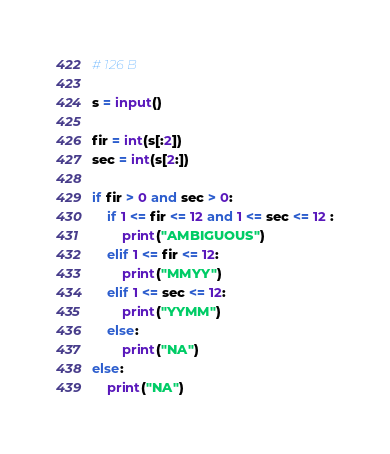Convert code to text. <code><loc_0><loc_0><loc_500><loc_500><_Python_># 126 B

s = input()

fir = int(s[:2])
sec = int(s[2:])

if fir > 0 and sec > 0:
    if 1 <= fir <= 12 and 1 <= sec <= 12 :
        print("AMBIGUOUS")
    elif 1 <= fir <= 12: 
        print("MMYY")
    elif 1 <= sec <= 12:
        print("YYMM") 
    else:
        print("NA")
else:
    print("NA")
</code> 